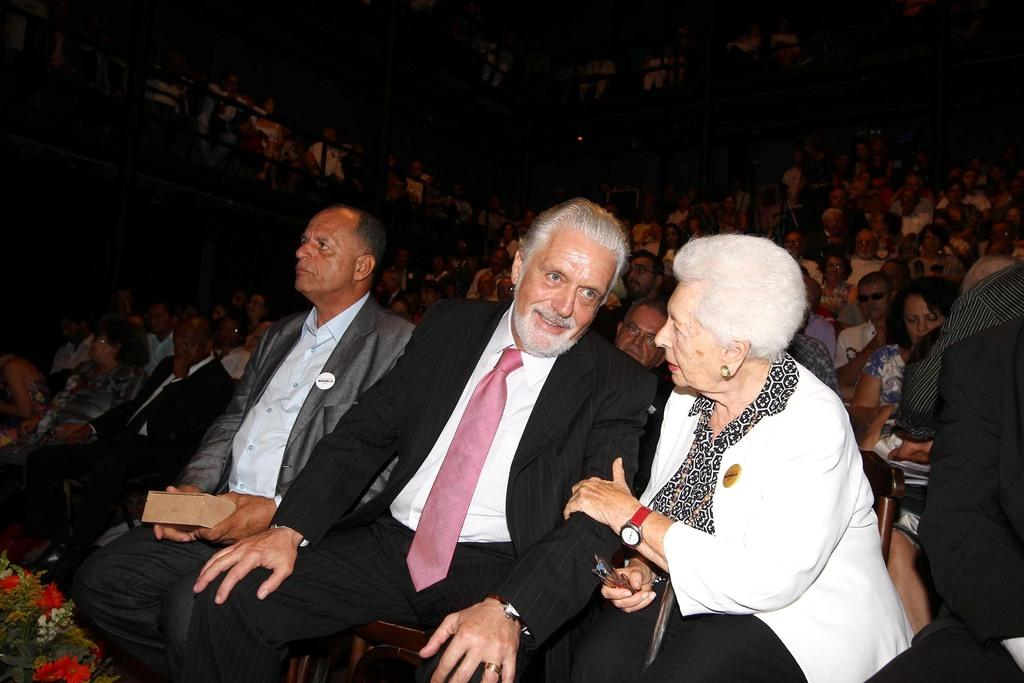How many people are sitting in chairs in the image? There are three persons sitting in chairs in the image. Are there any other people visible in the image? Yes, there are other people sitting behind them. What type of pail can be seen in the garden area of the image? There is no pail or garden area present in the image. 